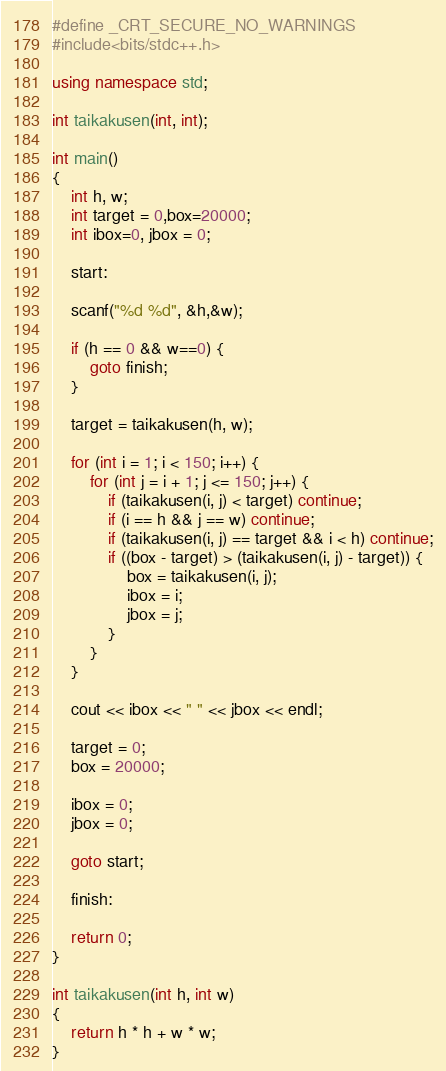<code> <loc_0><loc_0><loc_500><loc_500><_C++_>
#define _CRT_SECURE_NO_WARNINGS
#include<bits/stdc++.h>

using namespace std;

int taikakusen(int, int);

int main()
{
	int h, w;
	int target = 0,box=20000;
	int ibox=0, jbox = 0;

	start:

	scanf("%d %d", &h,&w);

	if (h == 0 && w==0) {
		goto finish;
	}

	target = taikakusen(h, w);

	for (int i = 1; i < 150; i++) {
		for (int j = i + 1; j <= 150; j++) {
			if (taikakusen(i, j) < target) continue;
			if (i == h && j == w) continue;
			if (taikakusen(i, j) == target && i < h) continue;
			if ((box - target) > (taikakusen(i, j) - target)) {
				box = taikakusen(i, j);
				ibox = i;
				jbox = j;
			}
		}
	}

	cout << ibox << " " << jbox << endl;

	target = 0;
	box = 20000;

	ibox = 0;
	jbox = 0;

	goto start;

	finish:

	return 0;
}

int taikakusen(int h, int w)
{
	return h * h + w * w;
}
</code> 